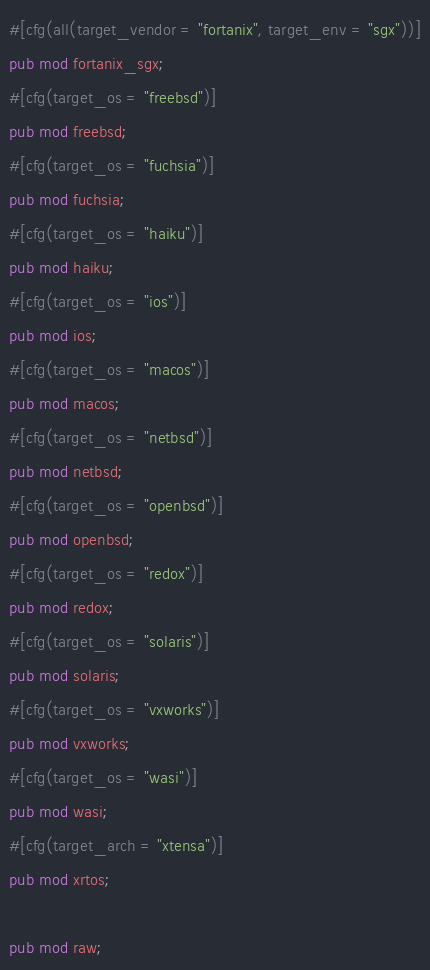<code> <loc_0><loc_0><loc_500><loc_500><_Rust_>#[cfg(all(target_vendor = "fortanix", target_env = "sgx"))]
pub mod fortanix_sgx;
#[cfg(target_os = "freebsd")]
pub mod freebsd;
#[cfg(target_os = "fuchsia")]
pub mod fuchsia;
#[cfg(target_os = "haiku")]
pub mod haiku;
#[cfg(target_os = "ios")]
pub mod ios;
#[cfg(target_os = "macos")]
pub mod macos;
#[cfg(target_os = "netbsd")]
pub mod netbsd;
#[cfg(target_os = "openbsd")]
pub mod openbsd;
#[cfg(target_os = "redox")]
pub mod redox;
#[cfg(target_os = "solaris")]
pub mod solaris;
#[cfg(target_os = "vxworks")]
pub mod vxworks;
#[cfg(target_os = "wasi")]
pub mod wasi;
#[cfg(target_arch = "xtensa")]
pub mod xrtos;

pub mod raw;
</code> 